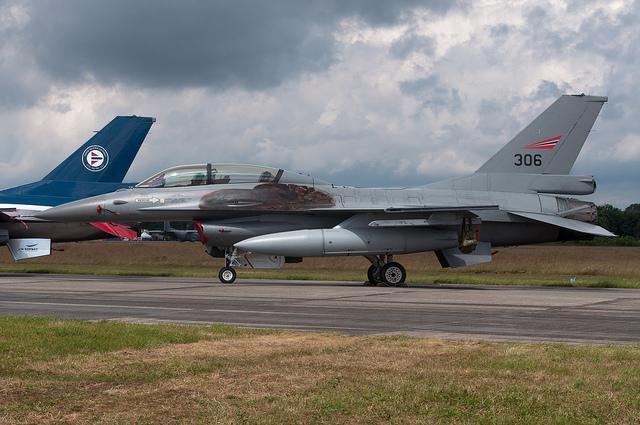How many airplanes are visible?
Give a very brief answer. 2. 